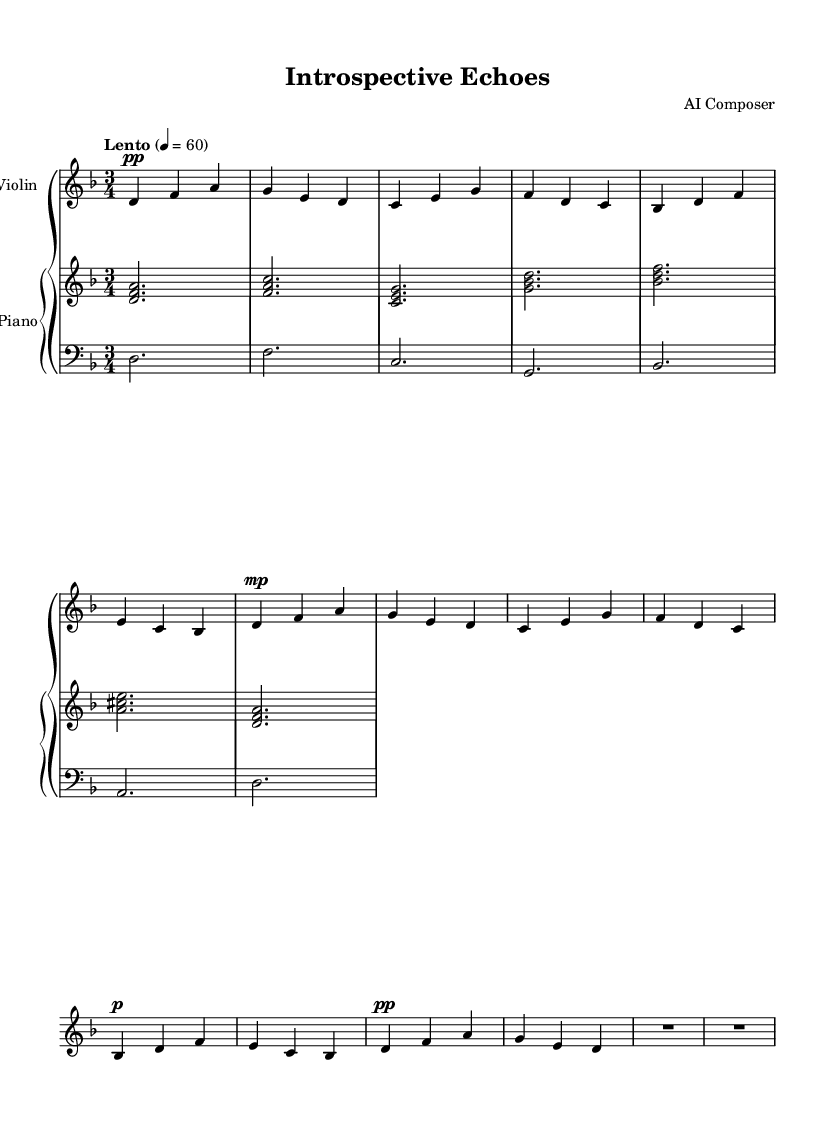What is the key signature of this music? The key signature is indicated at the beginning of the piece and is marked with the 'd' which indicates D minor, as reflected by the presence of one flat (B-flat).
Answer: D minor What is the time signature of this music? The time signature is observed at the start of the score, marked as 3/4, meaning there are three beats in each measure and the quarter note gets one beat.
Answer: 3/4 What is the tempo marking for this piece? The tempo is written at the beginning as "Lento" with a metronome marking of 60. This indicates a slow speed, referring specifically to the pace of the piece.
Answer: Lento, 60 How many measures does the piece contain? By counting the measures visually on the score, we find there are a total of 12 measures present throughout the piece.
Answer: 12 What instruments are featured in this piece? The instruments are specified at the beginning of the score in the staff naming, identifying the score for "Violin" and "Piano."
Answer: Violin and Piano Which dynamics are indicated for the violin part? The dynamics are marked specifically in the violin part, showing markings such as "pp" (pianissimo) and "mp" (mezzo-piano) indicating soft and moderately soft playing.
Answer: pp, mp What is the significance of the repeated notes in the piano part? The repeated notes create a sense of steadiness and introspection, integral to minimalist composition, emphasizing the reflective theme of life's complexities.
Answer: Introspection 